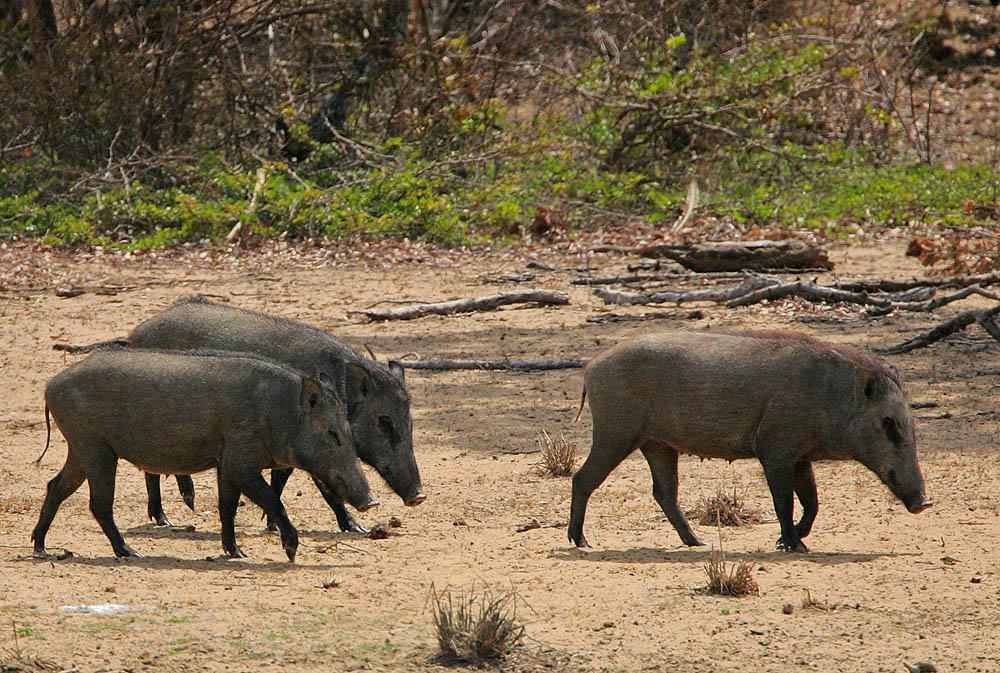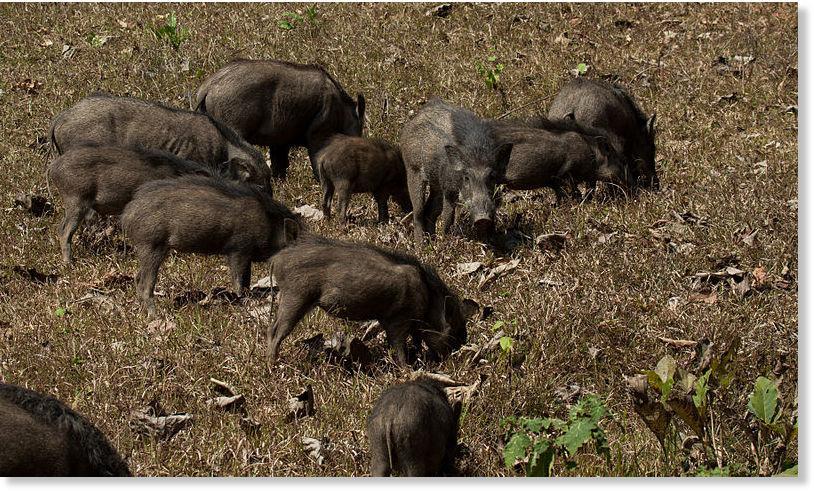The first image is the image on the left, the second image is the image on the right. Assess this claim about the two images: "There's more than one pig in each picture of the pair". Correct or not? Answer yes or no. Yes. 